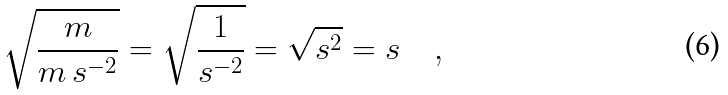<formula> <loc_0><loc_0><loc_500><loc_500>\sqrt { \frac { m } { m \, s ^ { - 2 } } } = \sqrt { \frac { 1 } { s ^ { - 2 } } } = \sqrt { s ^ { 2 } } = s \quad ,</formula> 